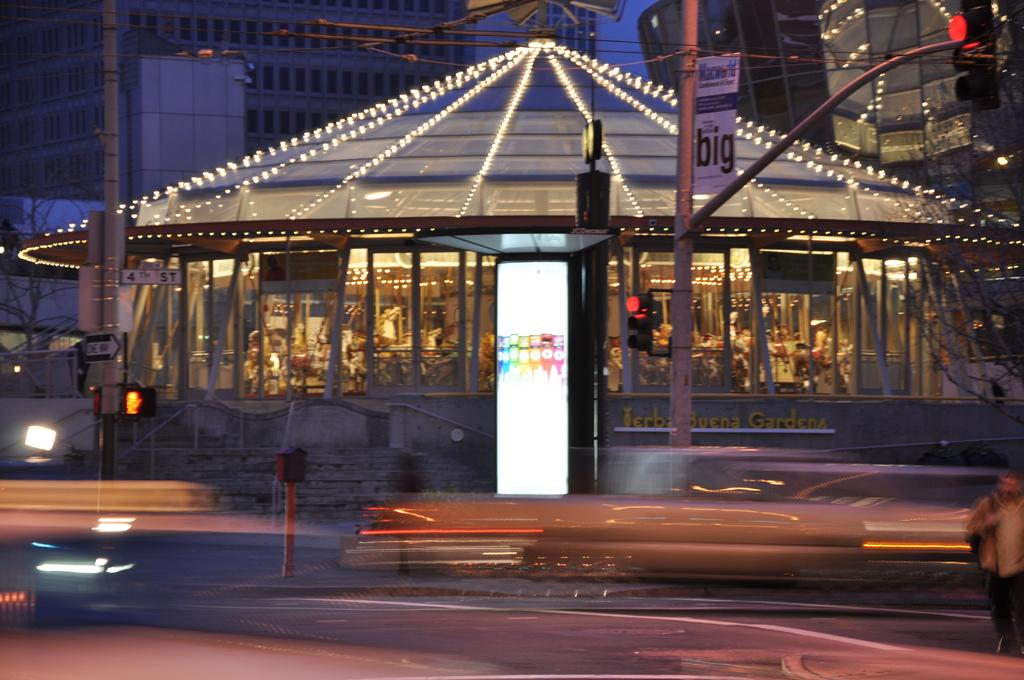What type of structures can be seen in the image? There are buildings in the image. What else is visible in the image besides the buildings? There are lights, a hoarding, a pole, and a traffic signal visible in the image. Can you describe the pole in the image? The pole is a vertical structure that supports the traffic signal. What is visible in the sky in the image? The sky is visible in the image. What type of pen is being used to write on the hoarding in the image? There is no pen visible in the image, and the hoarding does not appear to have any writing on it. What type of rod can be seen supporting the traffic signal in the image? There is no rod visible in the image; the traffic signal is supported by a pole. 